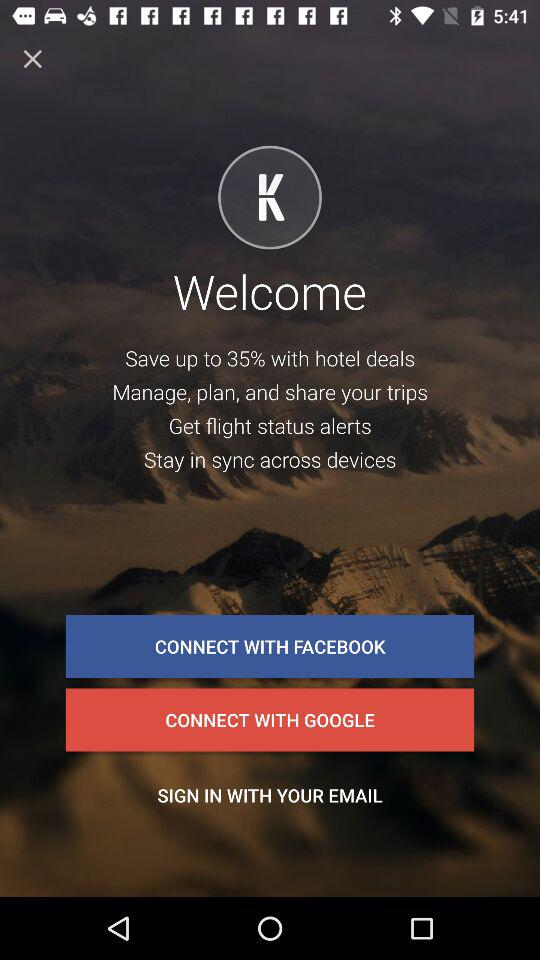What is the user's full name?
When the provided information is insufficient, respond with <no answer>. <no answer> 